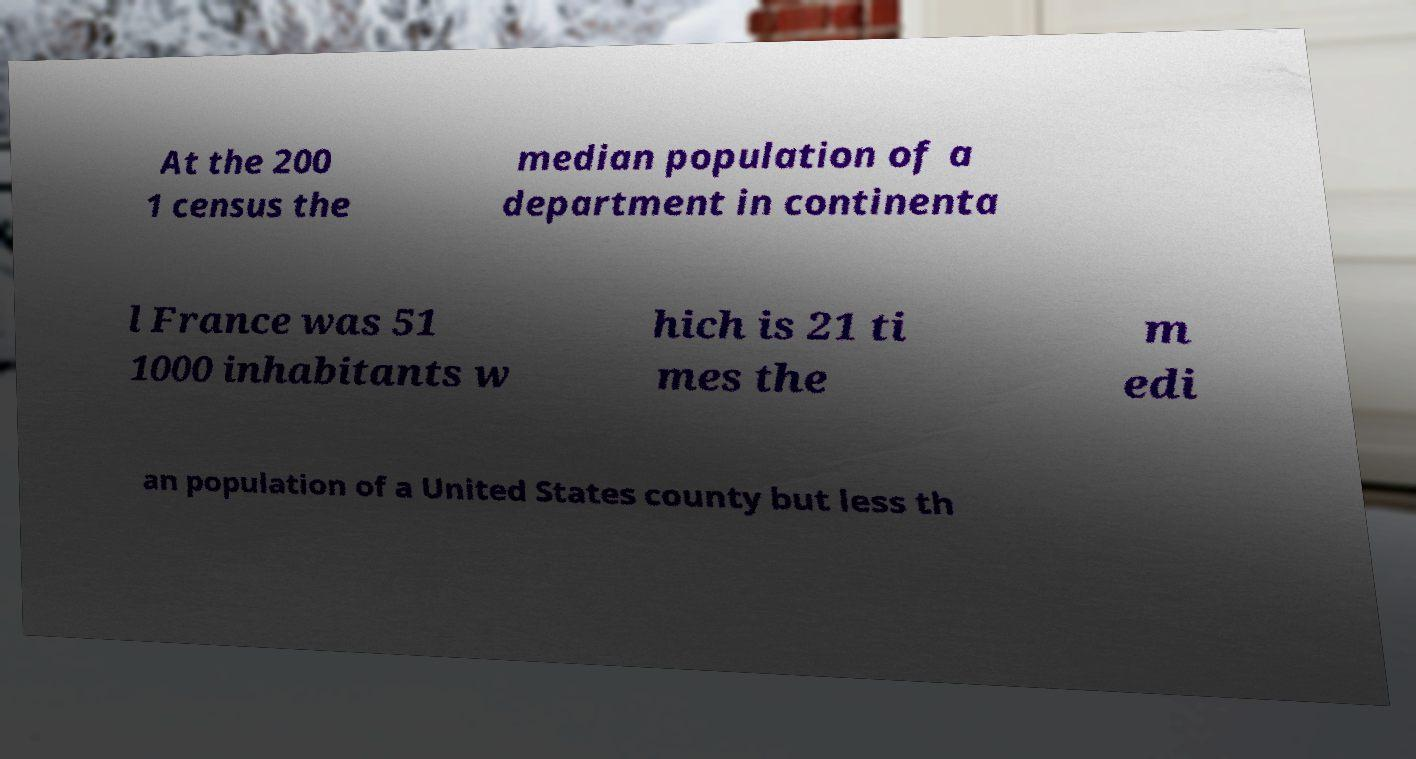Please identify and transcribe the text found in this image. At the 200 1 census the median population of a department in continenta l France was 51 1000 inhabitants w hich is 21 ti mes the m edi an population of a United States county but less th 